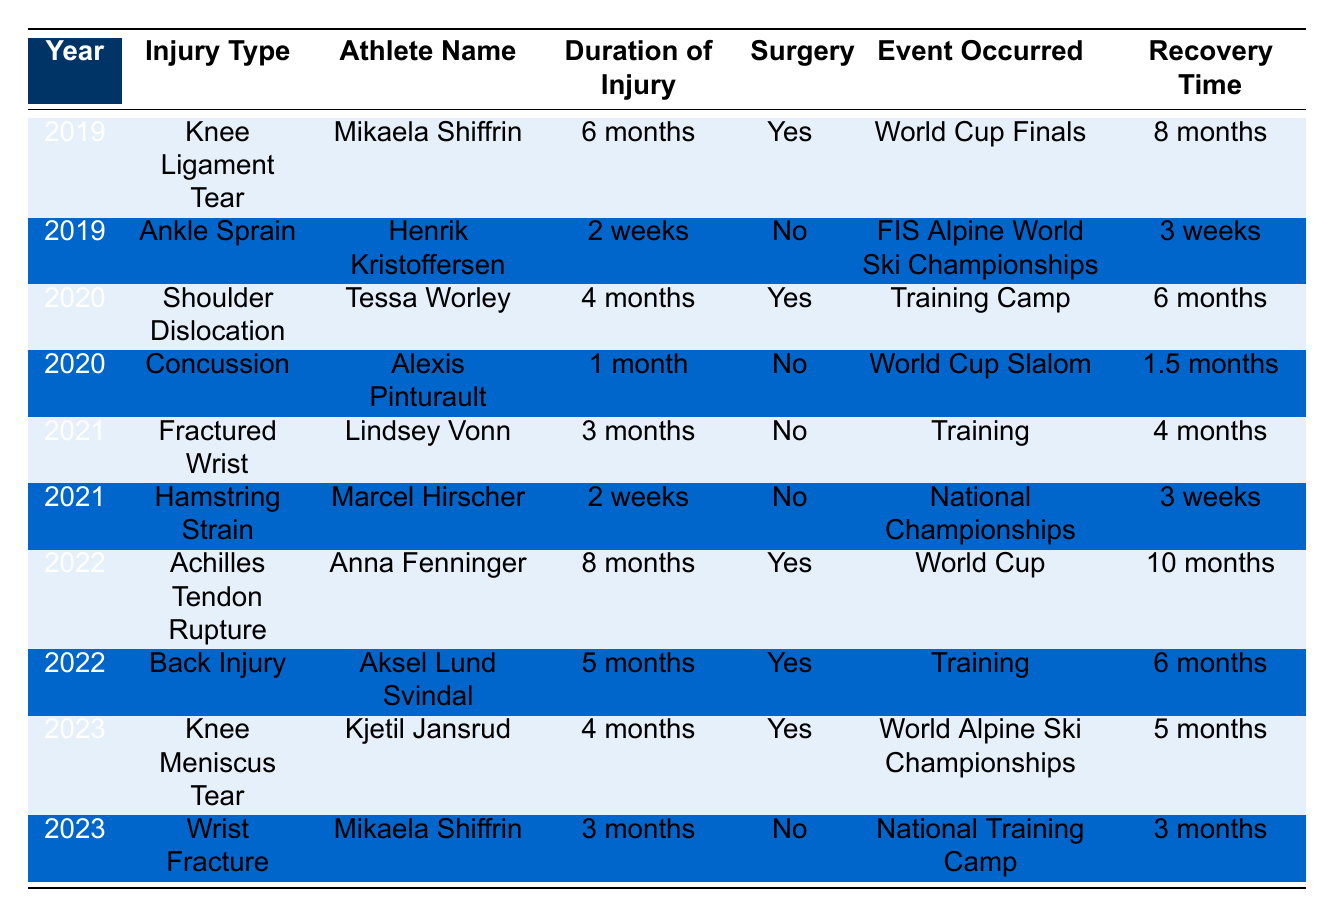What was the recovery time for Mikaela Shiffrin in 2019? From the table, under the entry for the year 2019 and athlete Mikaela Shiffrin, the recovery time listed is 8 months.
Answer: 8 months How many athletes underwent surgery for their injuries in 2020? By examining the entries for 2020, Tessa Worley (Shoulder Dislocation) had surgery, and Alexis Pinturault (Concussion) did not. Thus, only 1 athlete underwent surgery.
Answer: 1 What is the average recovery time for ankle injuries from the table? The only ankle injury listed is Henrik Kristoffersen's Ankle Sprain in 2019, with a recovery time of 3 weeks. Since there is only one data point, the average is also 3 weeks.
Answer: 3 weeks Did any athletes sustain knee injuries in 2023? The table shows that Kjetil Jansrud had a Knee Meniscus Tear in 2023, indicating there was at least one knee injury.
Answer: Yes Which type of injury had the longest duration of injury on record? Looking at the table, Anna Fenninger had an Achilles Tendon Rupture in 2022, which had a duration of 8 months, the longest recorded.
Answer: Achilles Tendon Rupture What is the total number of injuries reported in 2022? The table lists two entries for 2022: Anna Fenninger (Achilles Tendon Rupture) and Aksel Lund Svindal (Back Injury), resulting in a total of 2 injuries.
Answer: 2 Which athlete experienced a recovery time shorter than 1 month? In the table, the recovery time for Alexis Pinturault after his concussion in 2020 was 1.5 months, which is not shorter than 1 month; thus, none of the athletes had a recovery time shorter than 1 month.
Answer: No athletes What was the difference in recovery times between the longest and shortest injury durations? Anna Fenninger’s injury duration was 8 months, the longest, and Henrik Kristoffersen’s injury duration was 2 weeks, the shortest (about 0.5 months). The difference is 8 months - 0.5 months = 7.5 months.
Answer: 7.5 months How many athletes did not require surgery for their injuries across all years? By checking each athlete's entry, we find that Henrik Kristoffersen, Alexis Pinturault, Lindsey Vonn, Marcel Hirscher, and Mikaela Shiffrin (2 occurrences) did not have surgeries. That totals to 5 athletes.
Answer: 5 athletes In which year was the highest number of surgeries performed? The years are divided into injuries with and without surgeries. 2019 had 1 (Mikaela Shiffrin), 2020 had 1 (Tessa Worley), 2021 had 0 (Lindsey Vonn and Marcel Hirscher), 2022 had 2 (Anna Fenninger and Aksel Lund Svindal), and 2023 had 1 (Kjetil Jansrud). Thus, 2022 has the highest with 2 surgeries.
Answer: 2022 